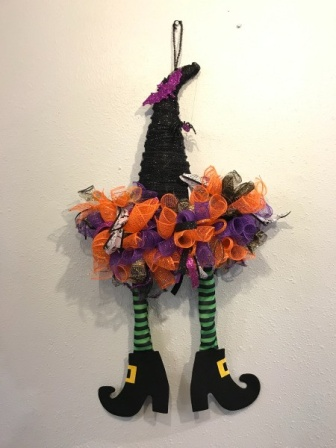What are the key elements in this picture? The image presents a Halloween-themed decoration on a white wall, instantly evoking the spooky season. At the center is a black witch's hat, accentuated with a vivid purple band and a shiny silver buckle, adding a pop of color. The hat is adorned with playful orange and purple mesh ribbons, as well as tinkling silver bells that lend a festive touch. Emerging whimsically from the hat are a pair of legs, bearing striking black and green stripes. The legs are humorously crossed at the ankles, and end in black shoes decorated with gold buckles. The entire setup is suspended from a silver hook, crafting an amusing visual of a witch disappearing into the wall, perfectly capturing a playful Halloween spirit. 